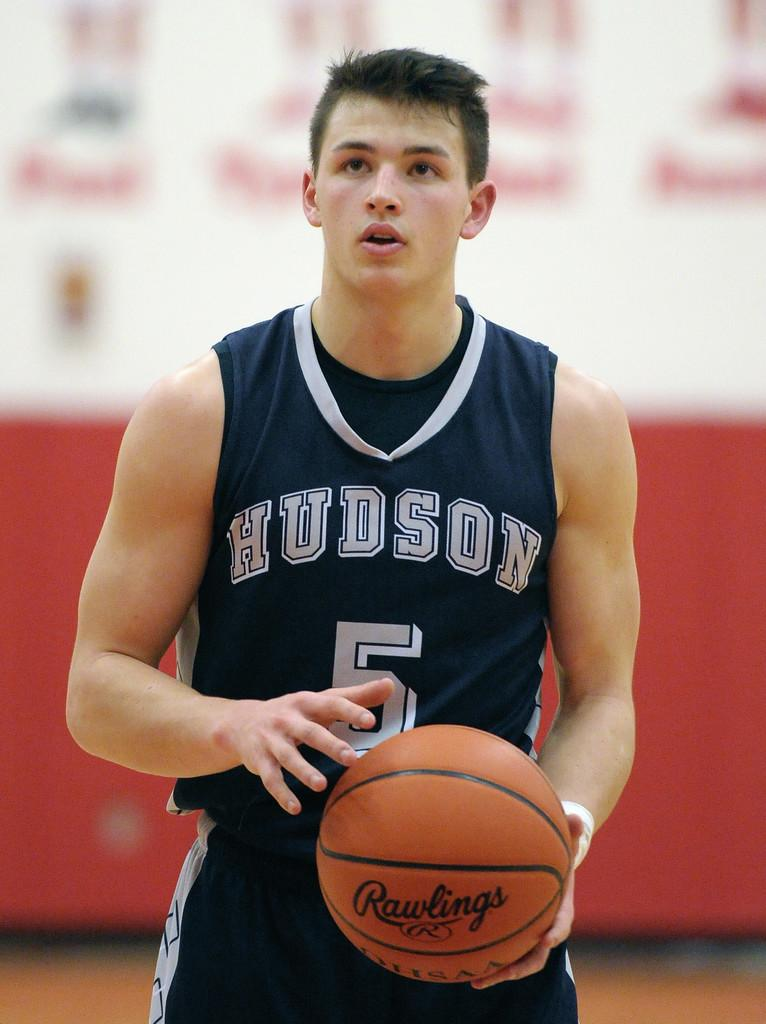<image>
Create a compact narrative representing the image presented. The basketball the player is using is made by Rawlings. 